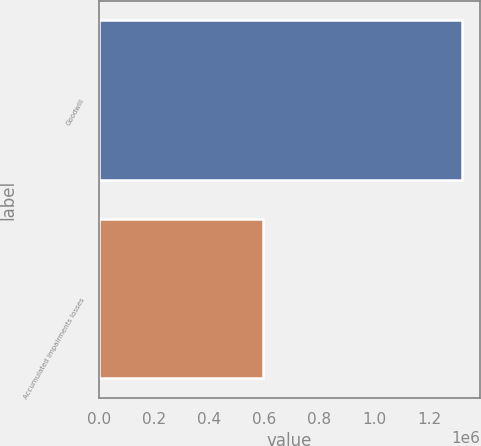Convert chart. <chart><loc_0><loc_0><loc_500><loc_500><bar_chart><fcel>Goodwill<fcel>Accumulated impairments losses<nl><fcel>1.31656e+06<fcel>596363<nl></chart> 